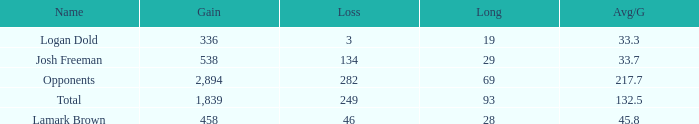How much Gain has a Long of 29, and an Avg/G smaller than 33.7? 0.0. 